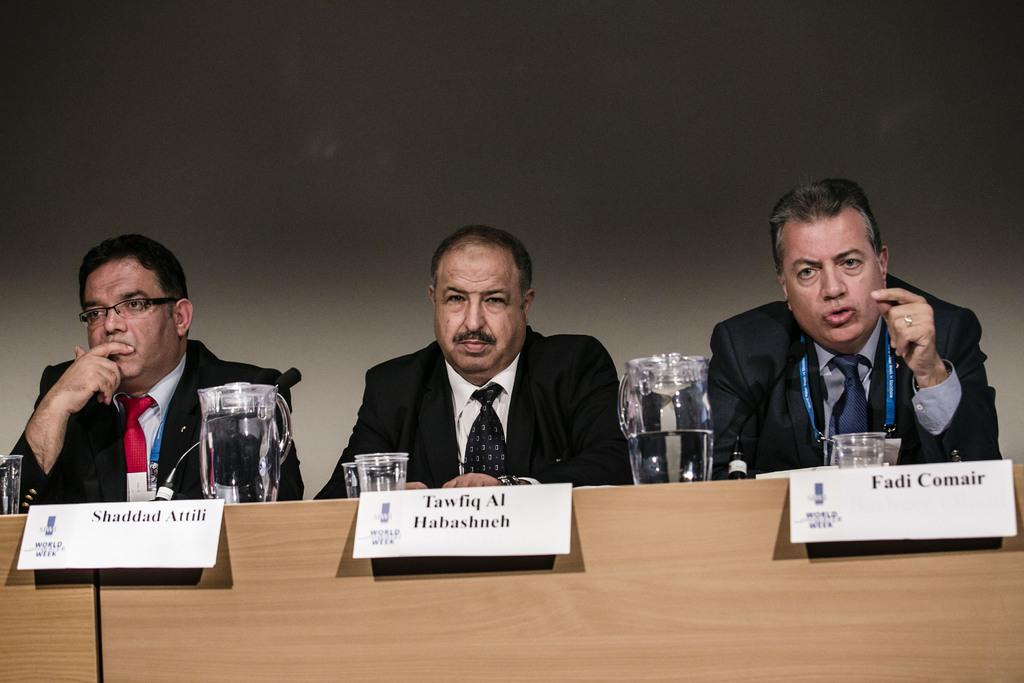How many people are sitting in the image? There are three persons sitting in the image. What objects are on the table? There are jugs, glasses, name plates, and mikes on the table. What can be seen in the background of the image? There is a wall in the background of the image. What type of hose is connected to the mikes on the table? There is no hose connected to the mikes on the table in the image. What is the relation between the persons sitting in the image? The provided facts do not give any information about the relationship between the persons sitting in the image. 